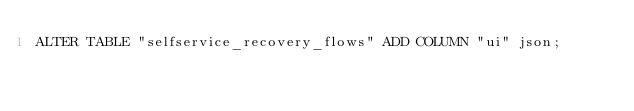Convert code to text. <code><loc_0><loc_0><loc_500><loc_500><_SQL_>ALTER TABLE "selfservice_recovery_flows" ADD COLUMN "ui" json;</code> 